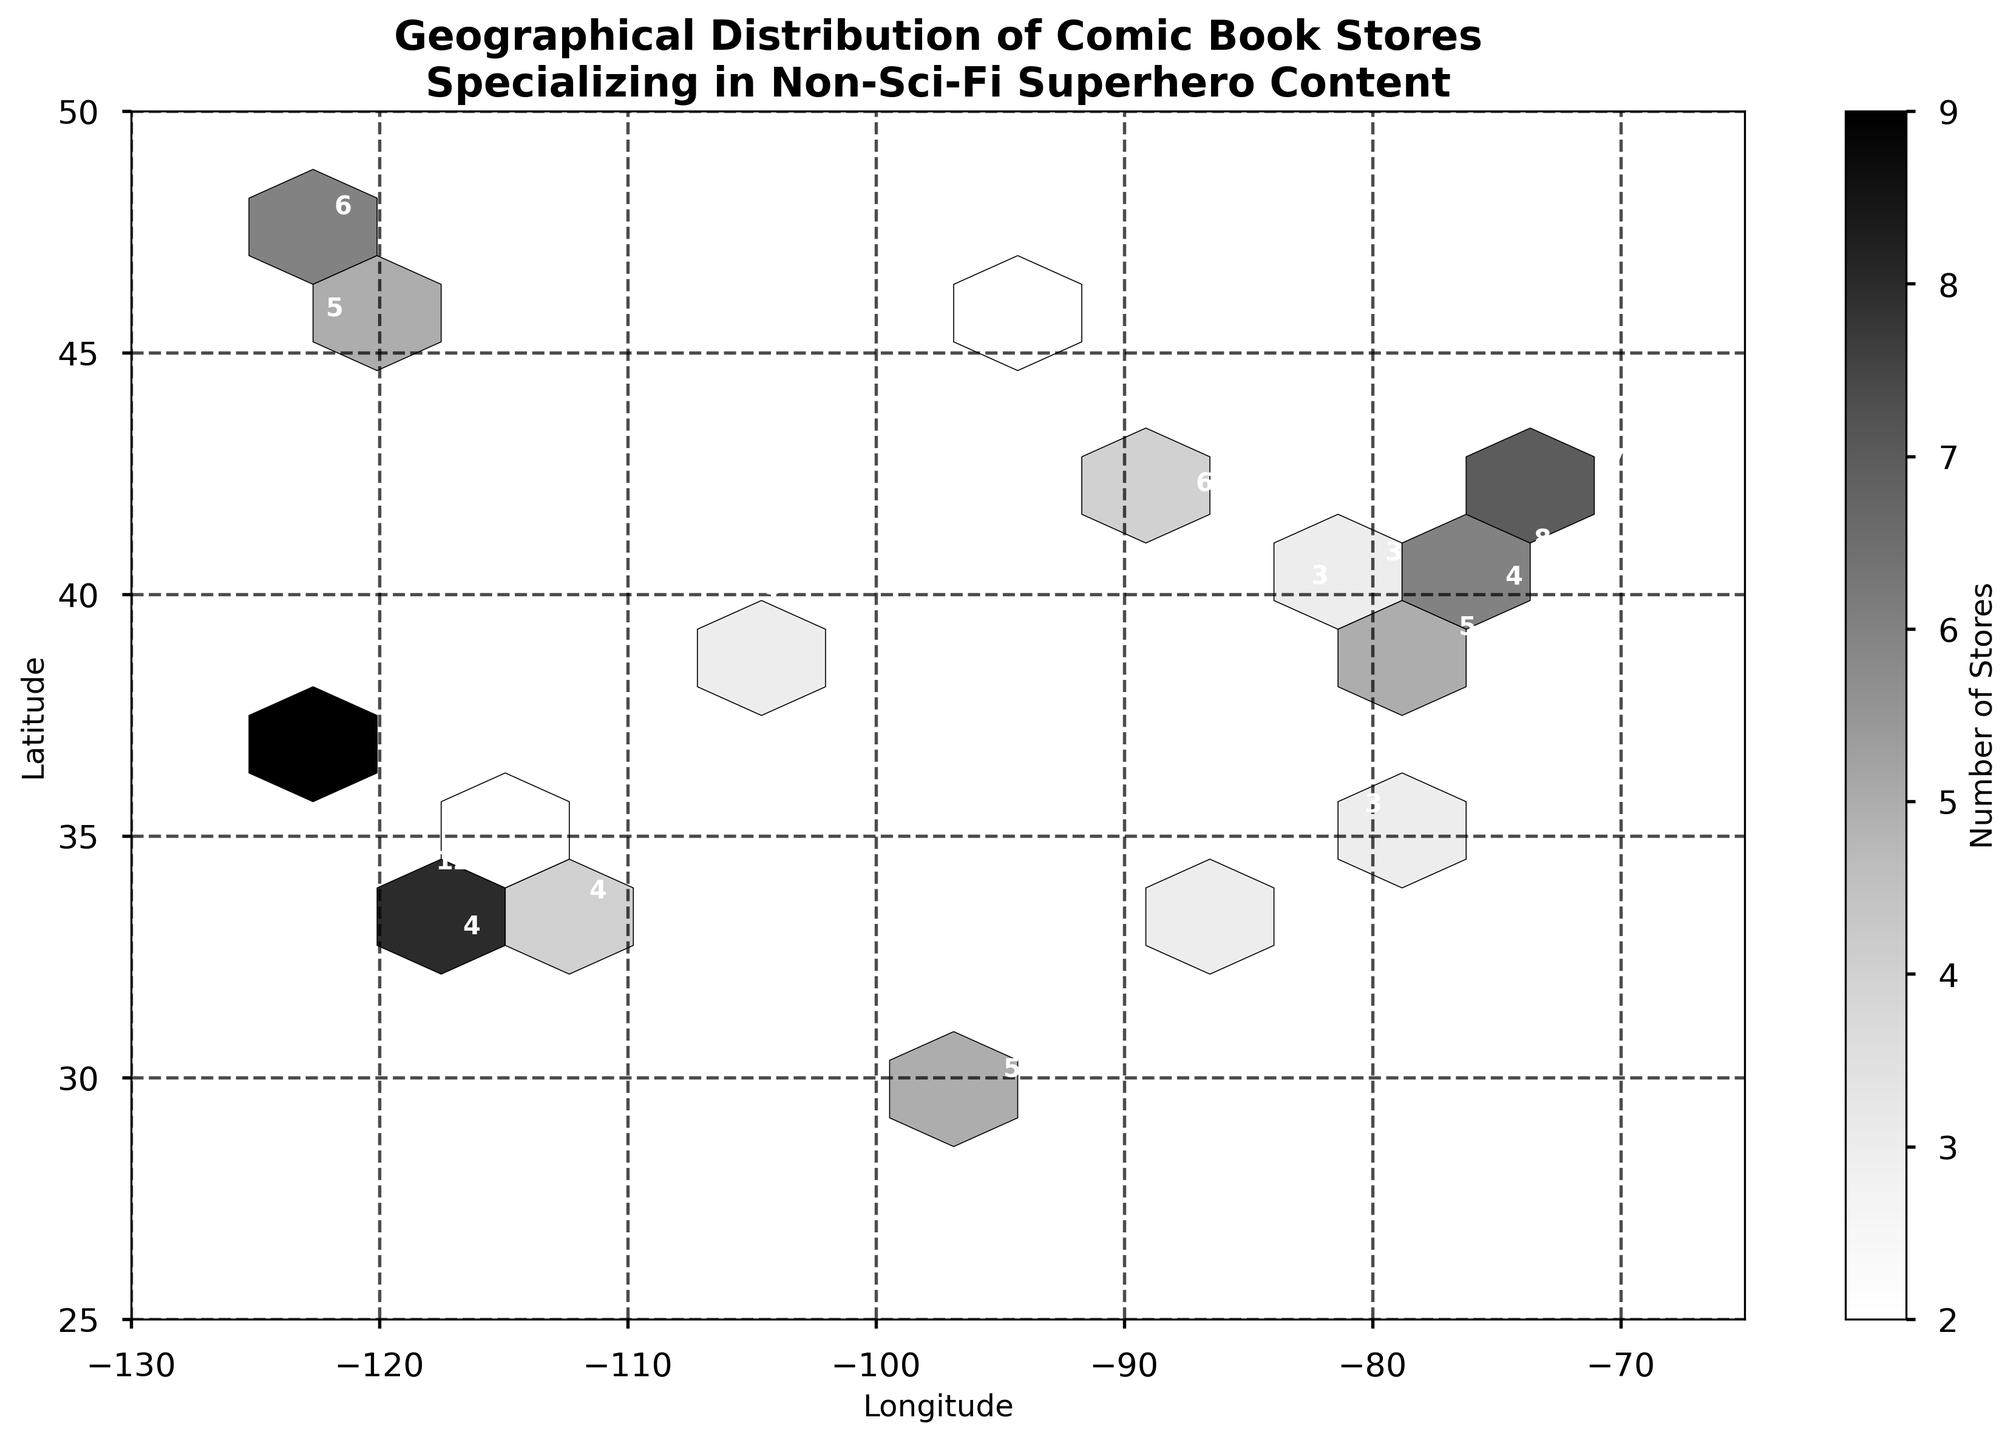What is the title of the hexbin plot? The title of the plot is usually positioned at the top of the figure. In this case, it states what the plot is about.
Answer: Geographical Distribution of Comic Book Stores Specializing in Non-Sci-Fi Superhero Content What are the axes labels of the plot? Axes labels are typically found beside the x and y axes, explaining what those axes represent. Here, you should see descriptions related to geography.
Answer: Longitude and Latitude What does the color scale in the hexbin plot represent? The color scale (grayscale in this case) usually represents the intensity of a specific measure. In this hexbin plot, it denotes a particular value.
Answer: Number of Stores Which city has the highest store count? The store count can be determined by looking at the numbers annotated on the plot. The city with the largest number is the one with the highest store count.
Answer: Los Angeles (12 stores) What range of latitude is covered in the hexbin plot? The y-axis of the plot represents latitude, and its range can be observed from the minimum and maximum points shown.
Answer: 25 to 50 How many cities have store counts greater than 5? By looking at the store counts annotated on the plot, count the number of cities with values higher than 5.
Answer: 5 cities (New York, Los Angeles, Chicago, Boston, San Francisco, Seattle) Which city has more stores: Chicago or Seattle? Compare the store counts annotated for Chicago and Seattle in the plot.
Answer: Seattle (6) has more stores than Chicago (6), so it's a tie Identify the city located closest to the coordinates (40, -75) and provide its store count. Approximate the coordinates (40, -75) on the plot and identify the nearest annotation.
Answer: Philadelphia (4 stores) What is the average store count of the cities in the plot? Sum up all the store counts annotated on the plot and divide by the total number of cities.
Answer: (8+12+6+5+7+4+3+5+4+3+2+3+9+6+2+3+2+3+4+5) / 20 = 93 / 20 = 4.65 How does the store distribution differ between the East and West Coasts? Observe and compare the density and store counts annotated on each coast. East Coast has larger counts and denser areas, West Coast has higher individual city counts but fewer packed areas.
Answer: The distribution on the East Coast is denser with generally smaller store counts per city, whereas the West Coast has fewer, higher-count cities 